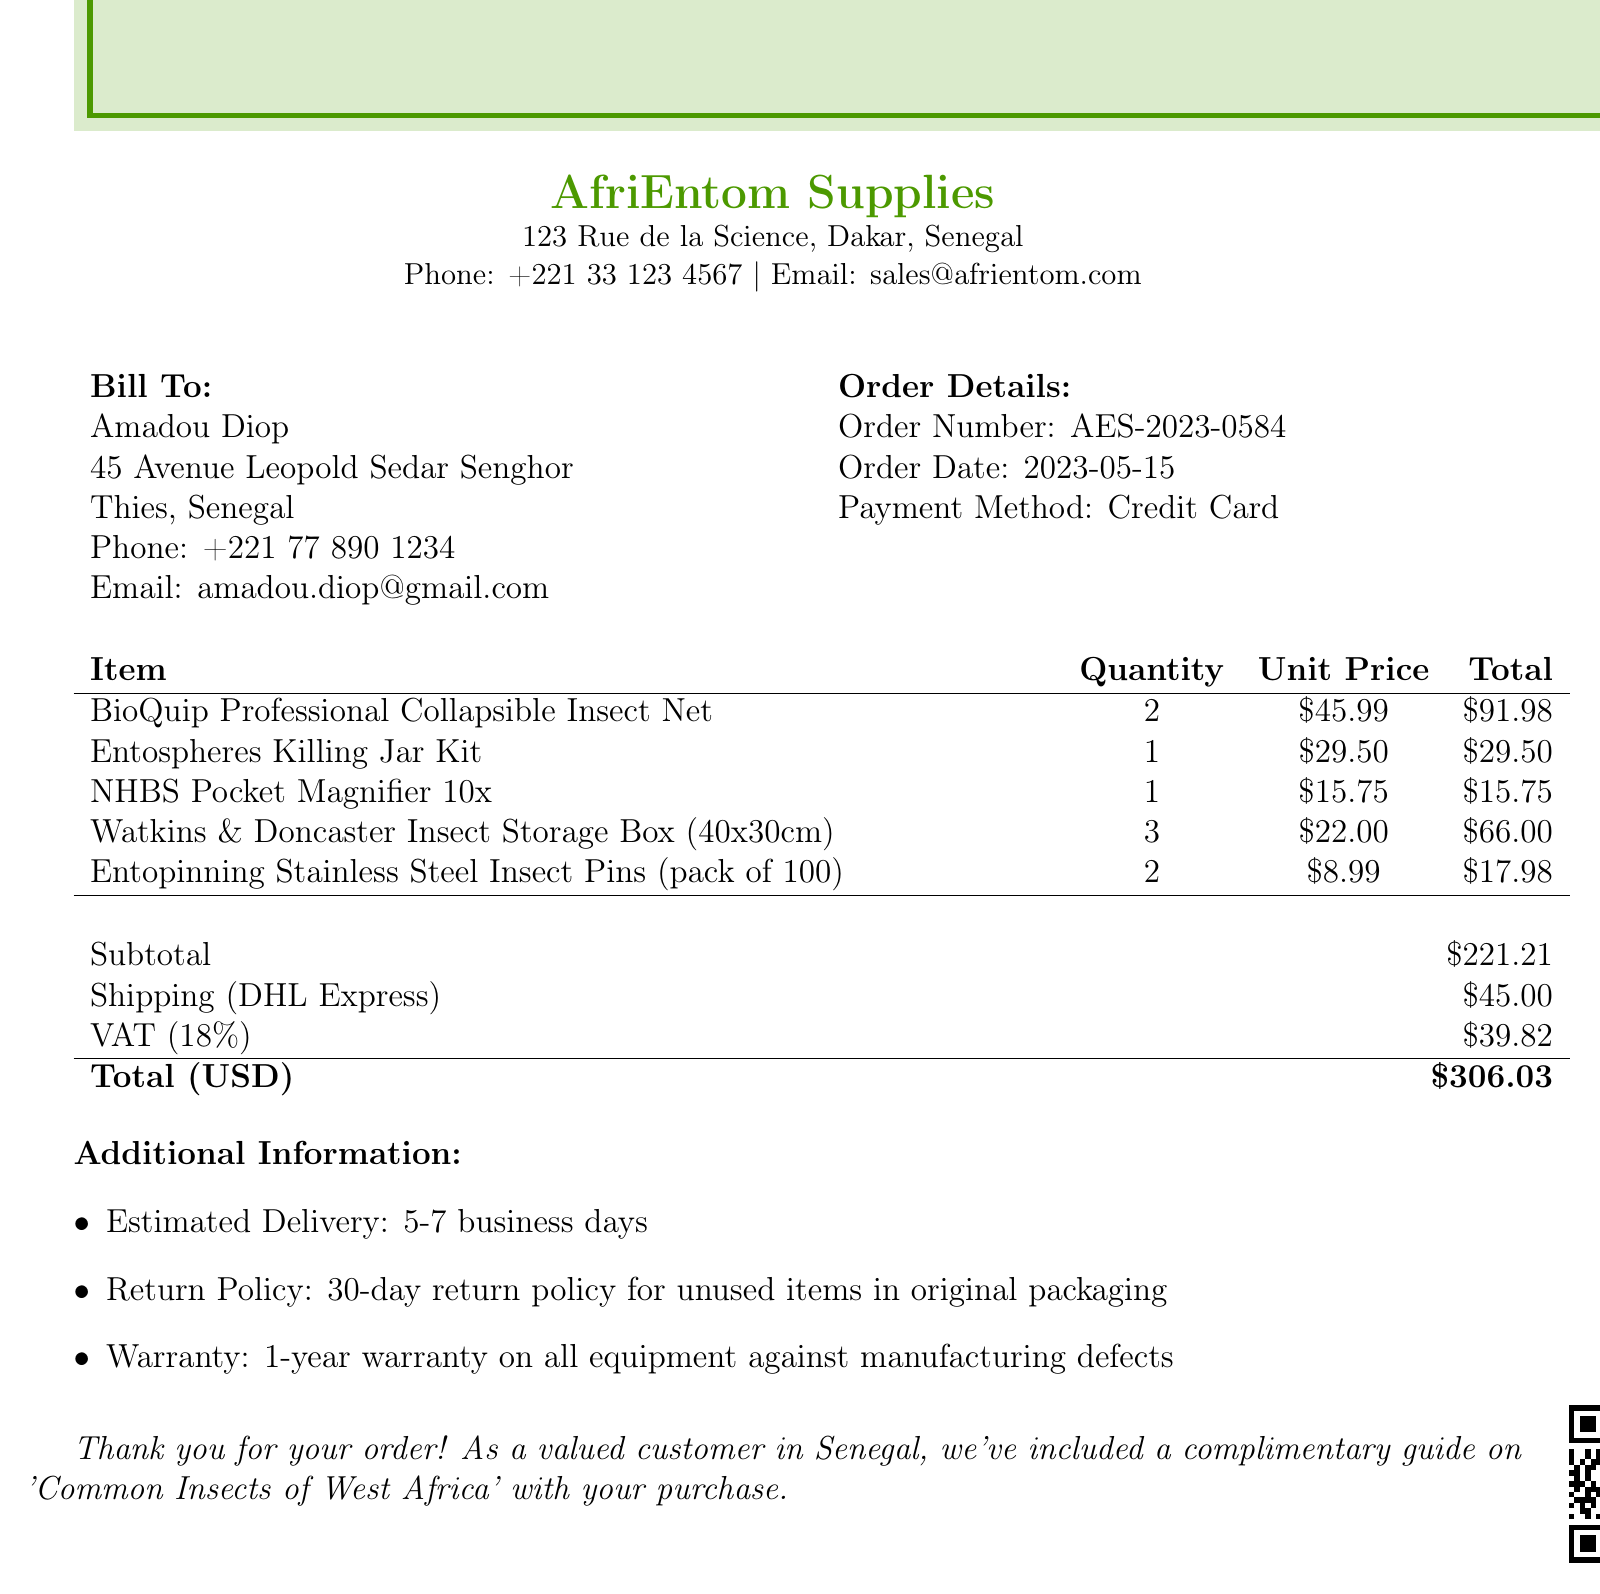what is the name of the supplier? The name of the supplier is mentioned at the top of the document.
Answer: AfriEntom Supplies what is the order date? The order date is specified in the order details section of the document.
Answer: 2023-05-15 how many BioQuip Professional Collapsible Insect Nets were purchased? The quantity of this item is detailed in the items list.
Answer: 2 what is the shipping cost? The shipping cost is provided in the shipping section of the document.
Answer: 45.00 what is the total amount due? The total amount is calculated and stated in the summary of the document.
Answer: 306.03 how much VAT was charged? The VAT amount is listed in the taxes section.
Answer: 39.82 what is the estimated delivery time? The estimated delivery time is stated in the additional information section.
Answer: 5-7 business days what is the warranty period for the equipment? The warranty period is outlined in the additional information.
Answer: 1-year what is the return policy for unused items? The return policy is described under additional information.
Answer: 30-day return policy for unused items in original packaging 